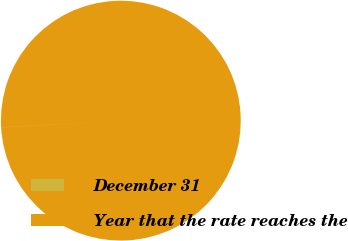Convert chart. <chart><loc_0><loc_0><loc_500><loc_500><pie_chart><fcel>December 31<fcel>Year that the rate reaches the<nl><fcel>0.01%<fcel>99.99%<nl></chart> 